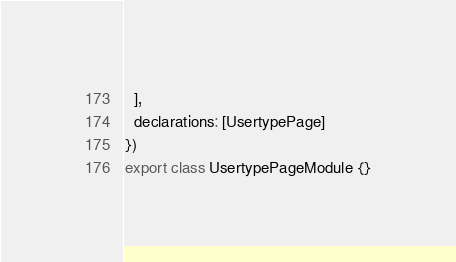Convert code to text. <code><loc_0><loc_0><loc_500><loc_500><_TypeScript_>  ],
  declarations: [UsertypePage]
})
export class UsertypePageModule {}
</code> 